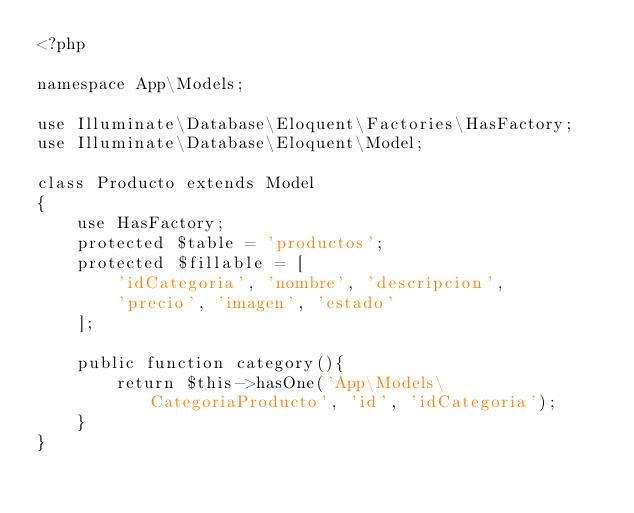<code> <loc_0><loc_0><loc_500><loc_500><_PHP_><?php

namespace App\Models;

use Illuminate\Database\Eloquent\Factories\HasFactory;
use Illuminate\Database\Eloquent\Model;

class Producto extends Model
{
    use HasFactory;
    protected $table = 'productos';
    protected $fillable = [
        'idCategoria', 'nombre', 'descripcion',
        'precio', 'imagen', 'estado'
    ];

    public function category(){
        return $this->hasOne('App\Models\CategoriaProducto', 'id', 'idCategoria');
    }
}
</code> 